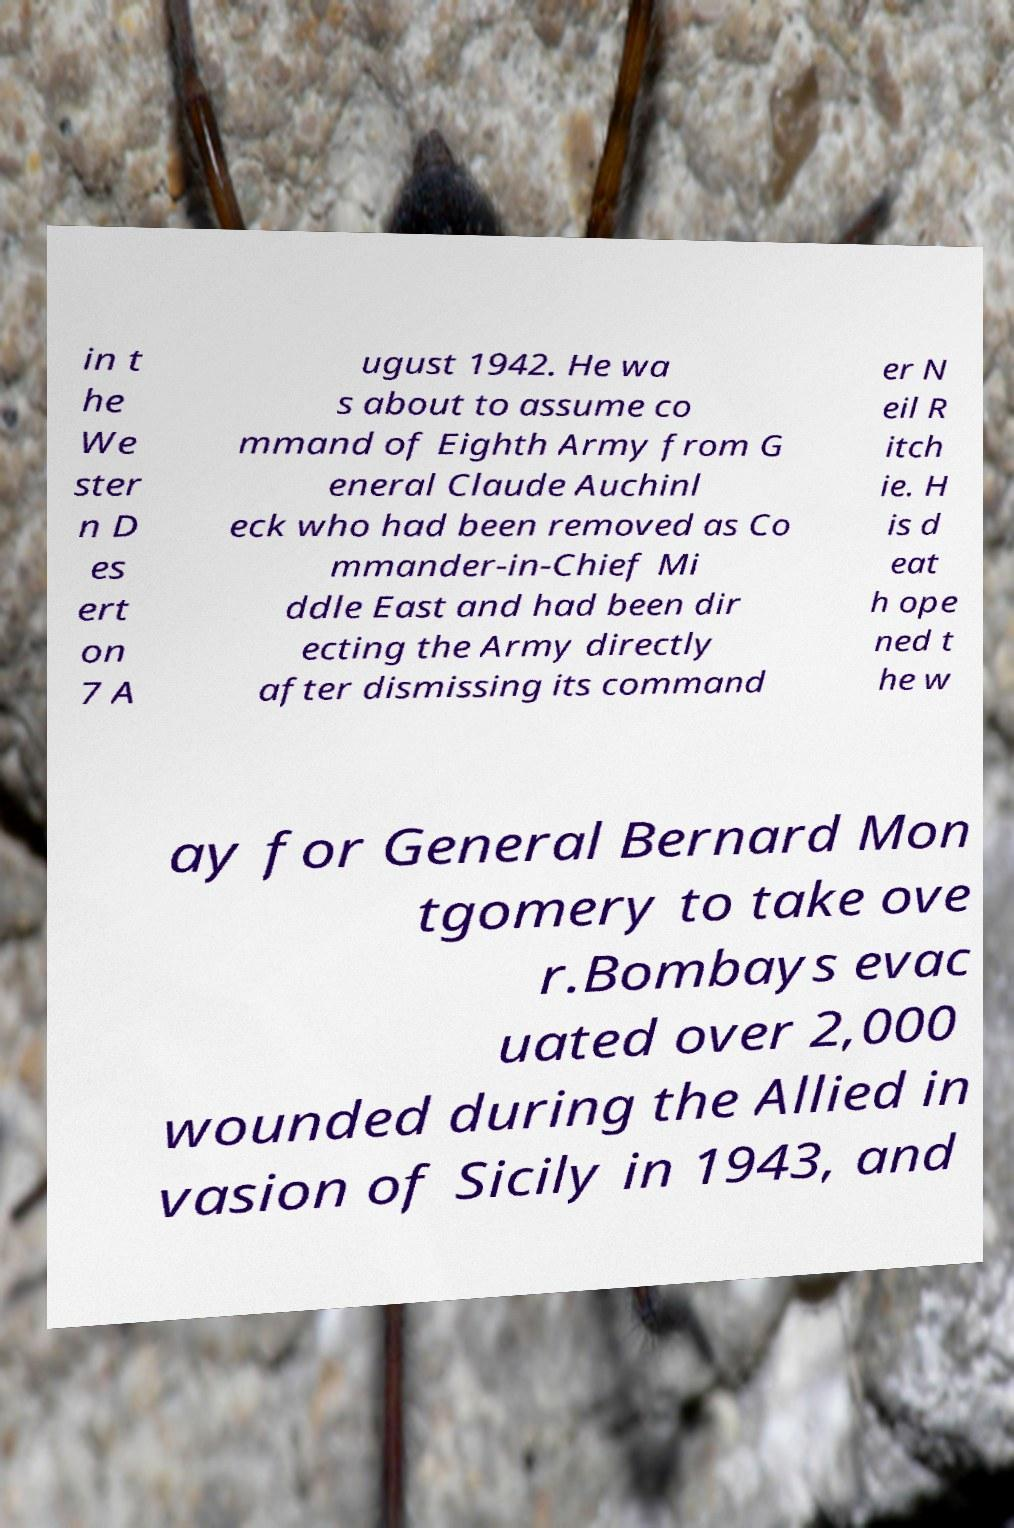There's text embedded in this image that I need extracted. Can you transcribe it verbatim? in t he We ster n D es ert on 7 A ugust 1942. He wa s about to assume co mmand of Eighth Army from G eneral Claude Auchinl eck who had been removed as Co mmander-in-Chief Mi ddle East and had been dir ecting the Army directly after dismissing its command er N eil R itch ie. H is d eat h ope ned t he w ay for General Bernard Mon tgomery to take ove r.Bombays evac uated over 2,000 wounded during the Allied in vasion of Sicily in 1943, and 